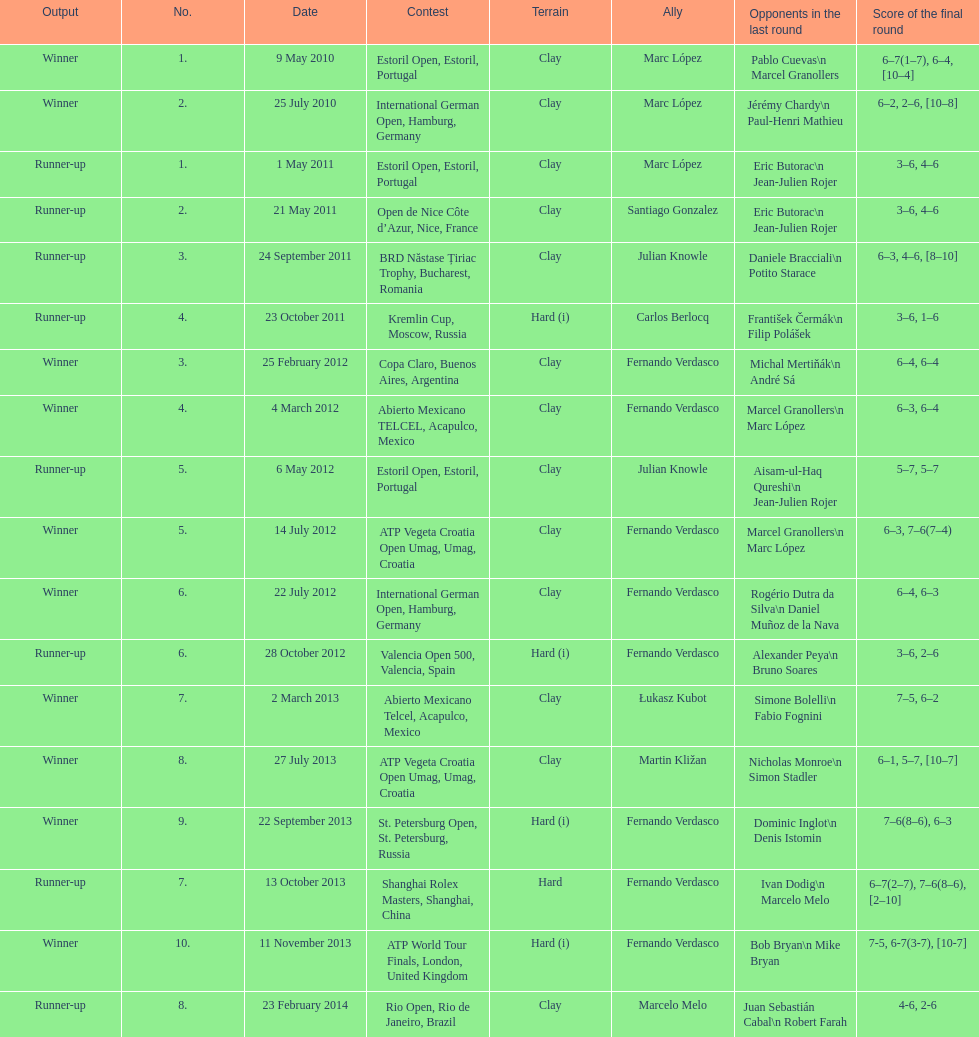What tournament was before the estoril open? Abierto Mexicano TELCEL, Acapulco, Mexico. Can you give me this table as a dict? {'header': ['Output', 'No.', 'Date', 'Contest', 'Terrain', 'Ally', 'Opponents in the last round', 'Score of the final round'], 'rows': [['Winner', '1.', '9 May 2010', 'Estoril Open, Estoril, Portugal', 'Clay', 'Marc López', 'Pablo Cuevas\\n Marcel Granollers', '6–7(1–7), 6–4, [10–4]'], ['Winner', '2.', '25 July 2010', 'International German Open, Hamburg, Germany', 'Clay', 'Marc López', 'Jérémy Chardy\\n Paul-Henri Mathieu', '6–2, 2–6, [10–8]'], ['Runner-up', '1.', '1 May 2011', 'Estoril Open, Estoril, Portugal', 'Clay', 'Marc López', 'Eric Butorac\\n Jean-Julien Rojer', '3–6, 4–6'], ['Runner-up', '2.', '21 May 2011', 'Open de Nice Côte d’Azur, Nice, France', 'Clay', 'Santiago Gonzalez', 'Eric Butorac\\n Jean-Julien Rojer', '3–6, 4–6'], ['Runner-up', '3.', '24 September 2011', 'BRD Năstase Țiriac Trophy, Bucharest, Romania', 'Clay', 'Julian Knowle', 'Daniele Bracciali\\n Potito Starace', '6–3, 4–6, [8–10]'], ['Runner-up', '4.', '23 October 2011', 'Kremlin Cup, Moscow, Russia', 'Hard (i)', 'Carlos Berlocq', 'František Čermák\\n Filip Polášek', '3–6, 1–6'], ['Winner', '3.', '25 February 2012', 'Copa Claro, Buenos Aires, Argentina', 'Clay', 'Fernando Verdasco', 'Michal Mertiňák\\n André Sá', '6–4, 6–4'], ['Winner', '4.', '4 March 2012', 'Abierto Mexicano TELCEL, Acapulco, Mexico', 'Clay', 'Fernando Verdasco', 'Marcel Granollers\\n Marc López', '6–3, 6–4'], ['Runner-up', '5.', '6 May 2012', 'Estoril Open, Estoril, Portugal', 'Clay', 'Julian Knowle', 'Aisam-ul-Haq Qureshi\\n Jean-Julien Rojer', '5–7, 5–7'], ['Winner', '5.', '14 July 2012', 'ATP Vegeta Croatia Open Umag, Umag, Croatia', 'Clay', 'Fernando Verdasco', 'Marcel Granollers\\n Marc López', '6–3, 7–6(7–4)'], ['Winner', '6.', '22 July 2012', 'International German Open, Hamburg, Germany', 'Clay', 'Fernando Verdasco', 'Rogério Dutra da Silva\\n Daniel Muñoz de la Nava', '6–4, 6–3'], ['Runner-up', '6.', '28 October 2012', 'Valencia Open 500, Valencia, Spain', 'Hard (i)', 'Fernando Verdasco', 'Alexander Peya\\n Bruno Soares', '3–6, 2–6'], ['Winner', '7.', '2 March 2013', 'Abierto Mexicano Telcel, Acapulco, Mexico', 'Clay', 'Łukasz Kubot', 'Simone Bolelli\\n Fabio Fognini', '7–5, 6–2'], ['Winner', '8.', '27 July 2013', 'ATP Vegeta Croatia Open Umag, Umag, Croatia', 'Clay', 'Martin Kližan', 'Nicholas Monroe\\n Simon Stadler', '6–1, 5–7, [10–7]'], ['Winner', '9.', '22 September 2013', 'St. Petersburg Open, St. Petersburg, Russia', 'Hard (i)', 'Fernando Verdasco', 'Dominic Inglot\\n Denis Istomin', '7–6(8–6), 6–3'], ['Runner-up', '7.', '13 October 2013', 'Shanghai Rolex Masters, Shanghai, China', 'Hard', 'Fernando Verdasco', 'Ivan Dodig\\n Marcelo Melo', '6–7(2–7), 7–6(8–6), [2–10]'], ['Winner', '10.', '11 November 2013', 'ATP World Tour Finals, London, United Kingdom', 'Hard (i)', 'Fernando Verdasco', 'Bob Bryan\\n Mike Bryan', '7-5, 6-7(3-7), [10-7]'], ['Runner-up', '8.', '23 February 2014', 'Rio Open, Rio de Janeiro, Brazil', 'Clay', 'Marcelo Melo', 'Juan Sebastián Cabal\\n Robert Farah', '4-6, 2-6']]} 